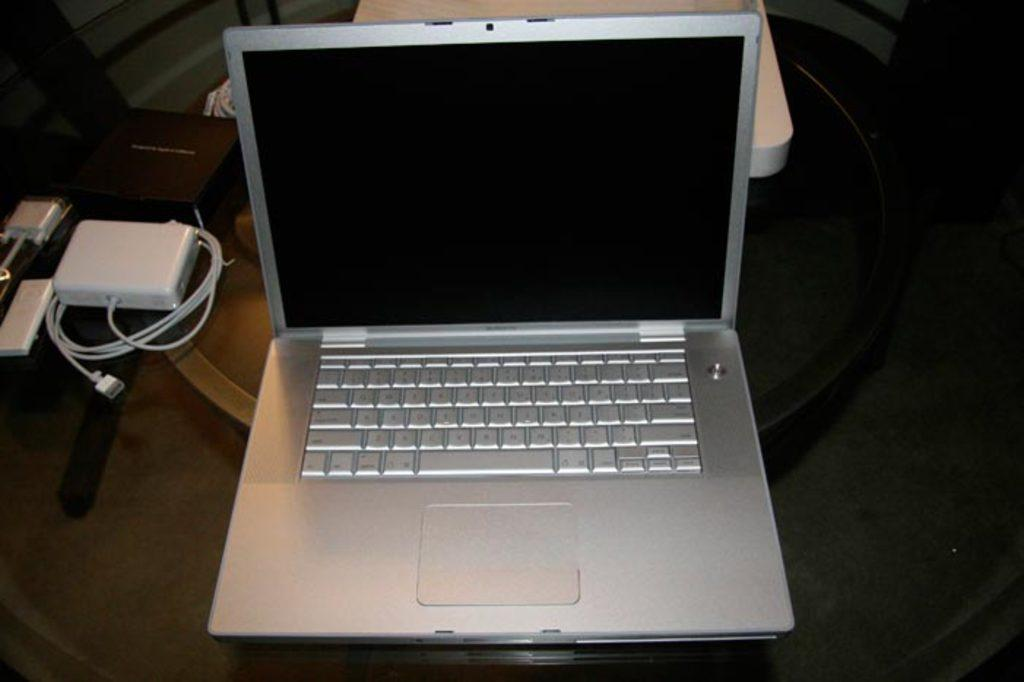What electronic device is visible in the image? There is a laptop in the image. Where is the laptop located? The laptop is on a table. What other object related to the laptop can be seen in the image? There is a charger box in the image. On what type of table is the charger box placed? The charger box is on a glass table. Which direction is the person facing in the image? There is no person present in the image. Can the person in the image open the can of soda? There is no person or can of soda present in the image. 